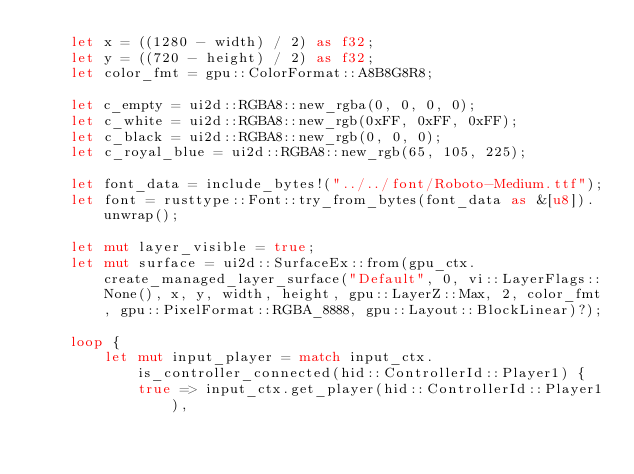<code> <loc_0><loc_0><loc_500><loc_500><_Rust_>    let x = ((1280 - width) / 2) as f32;
    let y = ((720 - height) / 2) as f32;
    let color_fmt = gpu::ColorFormat::A8B8G8R8;

    let c_empty = ui2d::RGBA8::new_rgba(0, 0, 0, 0);
    let c_white = ui2d::RGBA8::new_rgb(0xFF, 0xFF, 0xFF);
    let c_black = ui2d::RGBA8::new_rgb(0, 0, 0);
    let c_royal_blue = ui2d::RGBA8::new_rgb(65, 105, 225);

    let font_data = include_bytes!("../../font/Roboto-Medium.ttf");
    let font = rusttype::Font::try_from_bytes(font_data as &[u8]).unwrap();

    let mut layer_visible = true;
    let mut surface = ui2d::SurfaceEx::from(gpu_ctx.create_managed_layer_surface("Default", 0, vi::LayerFlags::None(), x, y, width, height, gpu::LayerZ::Max, 2, color_fmt, gpu::PixelFormat::RGBA_8888, gpu::Layout::BlockLinear)?);

    loop {
        let mut input_player = match input_ctx.is_controller_connected(hid::ControllerId::Player1) {
            true => input_ctx.get_player(hid::ControllerId::Player1),</code> 